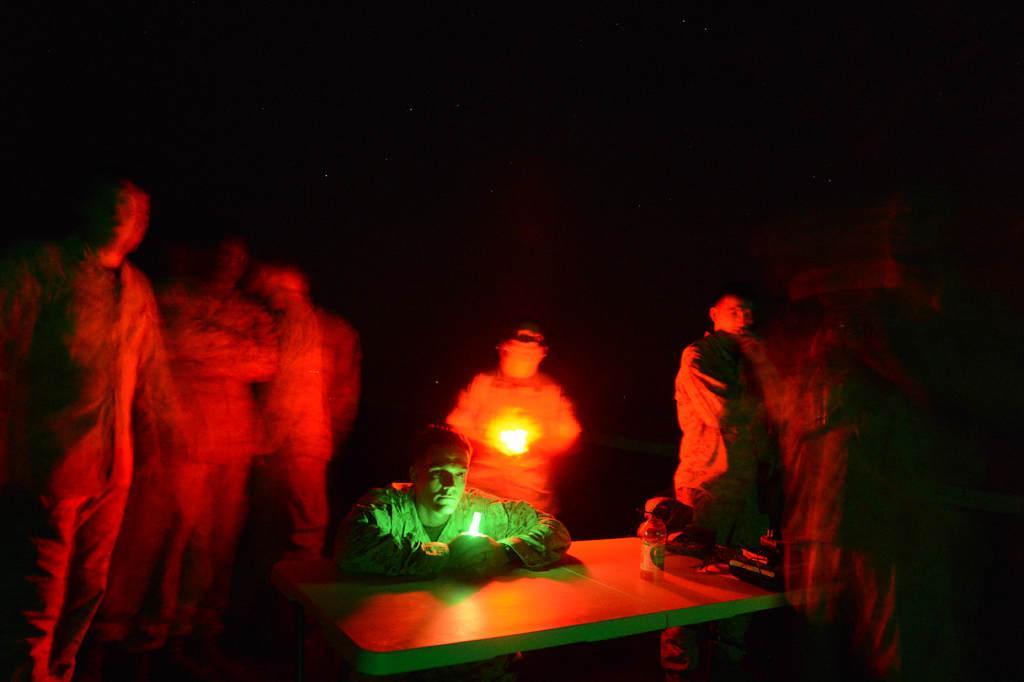How would you summarize this image in a sentence or two? In this image we can see a group of persons. In the middle we can see a person holding a light. In the foreground there are few objects on a table. The background of the image is dark. 